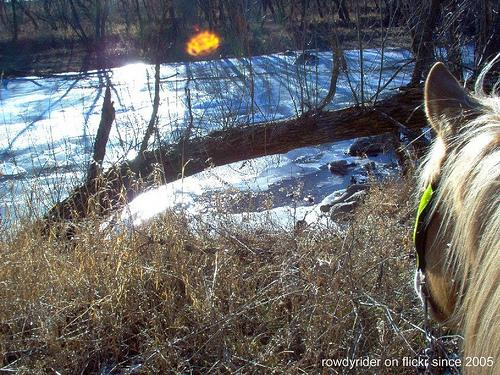Enumerate the types of vegetation seen in the image. Tree line along bank, small trees along river, tall grass, and dead or dried brown grass or weeds. Describe the environment around the horse. The horse is standing near a frozen river surrounded by tall brown grass, dead weeds, small trees, and a fallen tree trunk. Detail the significant characteristics of the river's surroundings. There are several dark rocks in the water, frozen water ice on the bank, and a horizontal tree trunk bent over the river. Compose a sentimental interpretation of the scene based on the image elements. The scene evokes a sense of calmness and serenity as a light-colored horse stands peacefully by a frozen river amid a quiet, wintry landscape. Mention any interesting or out-of-the-ordinary attributes of the river. The river is frozen, with a break in the ice underneath the fallen tree and sun shining on its surface. What is the main object in the image? A horse with a blonde mane standing by the water. Quantify the number of rocks in the middle of the stream or path. There are rocks in three separate clusters, totaling 260 rocks in the middle of the stream or path. Identify any notable features of the horse's accessories or appearance. The horse is wearing a brown bridle with a bright green cheek piece, and a green harness on its head. Analyze the horse's interaction with its environment in the image. The horse appears to be observing the frozen river, facing out with its one ear visible, possibly listening to the sounds of the surrounding environment. Report any distinctive elements or events occurring in the environment. There is a yellow or orange colored glow, possibly a lens flare, and sun reflecting on the frozen river's ice surface. 